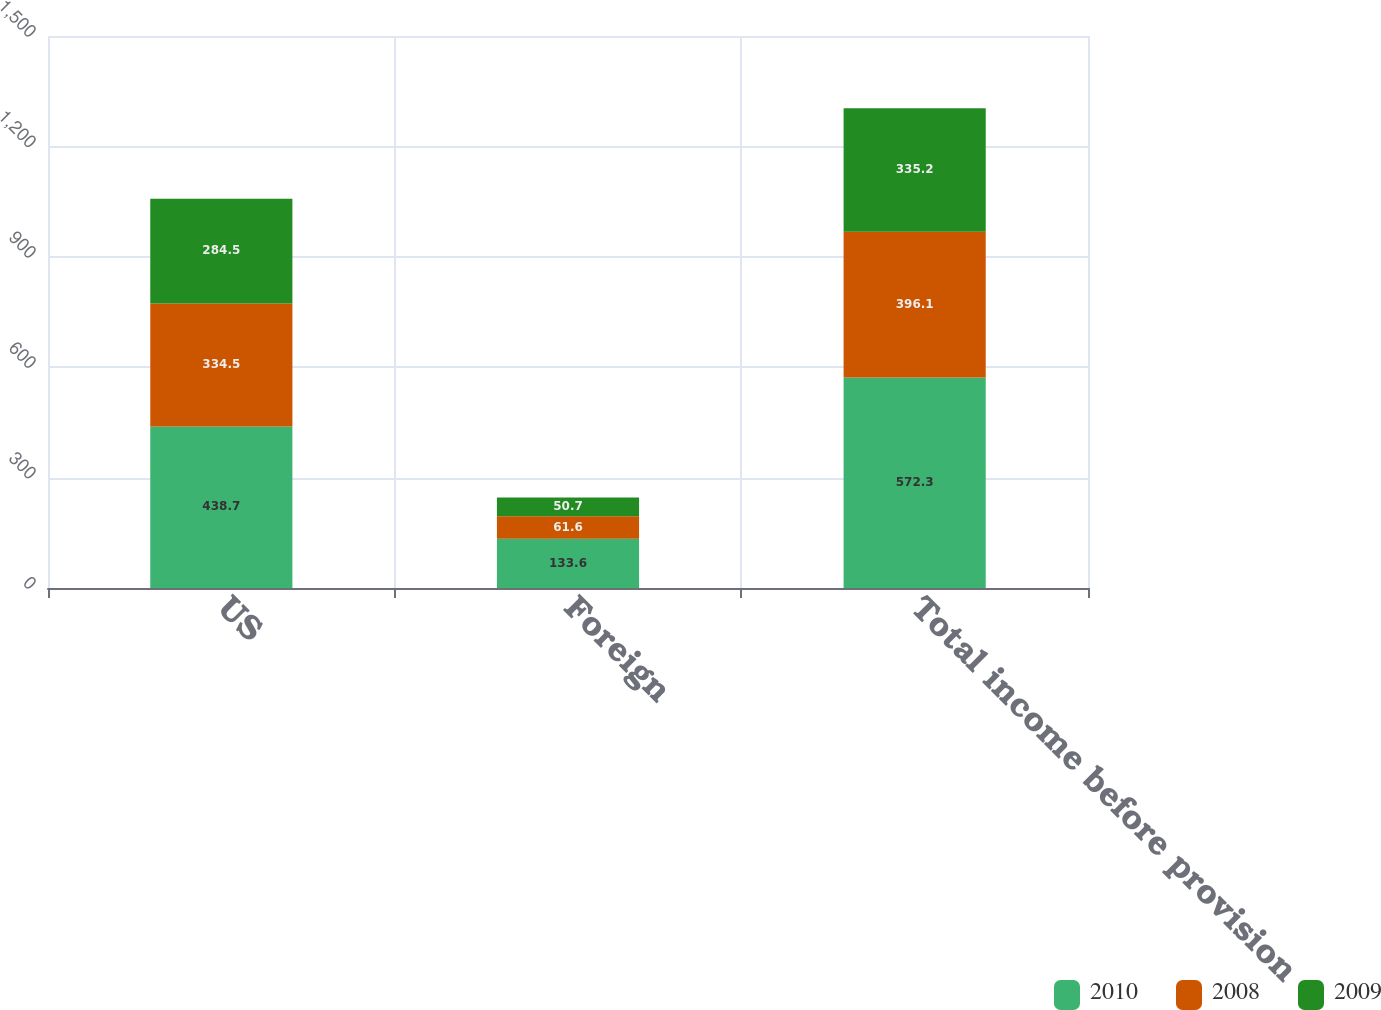Convert chart to OTSL. <chart><loc_0><loc_0><loc_500><loc_500><stacked_bar_chart><ecel><fcel>US<fcel>Foreign<fcel>Total income before provision<nl><fcel>2010<fcel>438.7<fcel>133.6<fcel>572.3<nl><fcel>2008<fcel>334.5<fcel>61.6<fcel>396.1<nl><fcel>2009<fcel>284.5<fcel>50.7<fcel>335.2<nl></chart> 